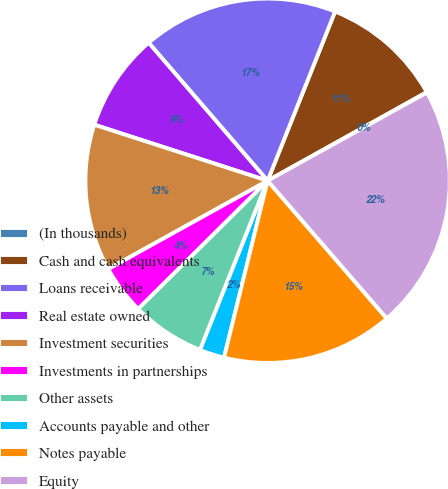<chart> <loc_0><loc_0><loc_500><loc_500><pie_chart><fcel>(In thousands)<fcel>Cash and cash equivalents<fcel>Loans receivable<fcel>Real estate owned<fcel>Investment securities<fcel>Investments in partnerships<fcel>Other assets<fcel>Accounts payable and other<fcel>Notes payable<fcel>Equity<nl><fcel>0.04%<fcel>10.87%<fcel>17.36%<fcel>8.7%<fcel>13.03%<fcel>4.37%<fcel>6.53%<fcel>2.2%<fcel>15.2%<fcel>21.7%<nl></chart> 